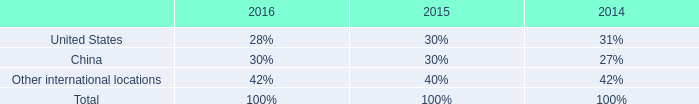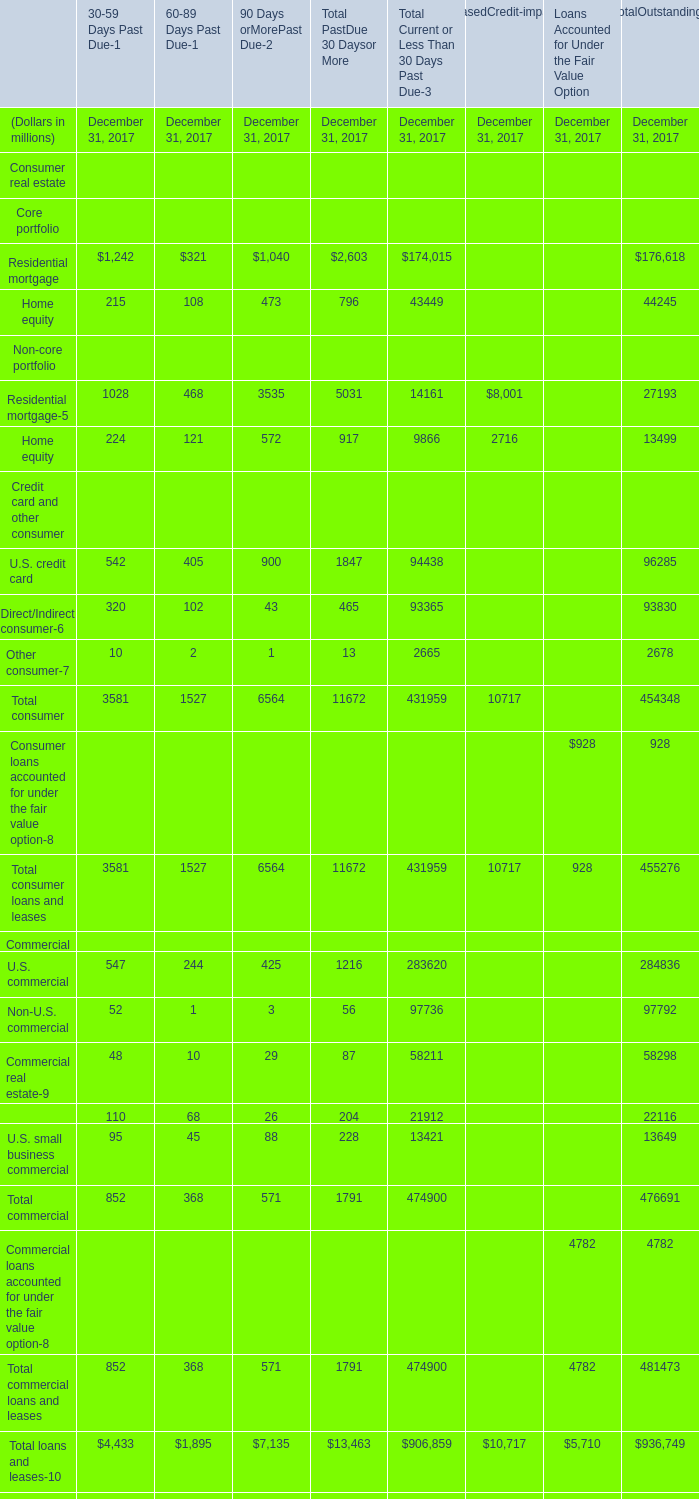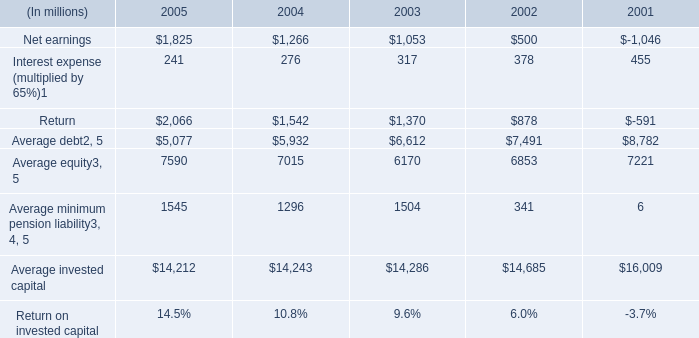What is the amount of the term with the highest total loans and leases? (in million) 
Answer: 936749. 